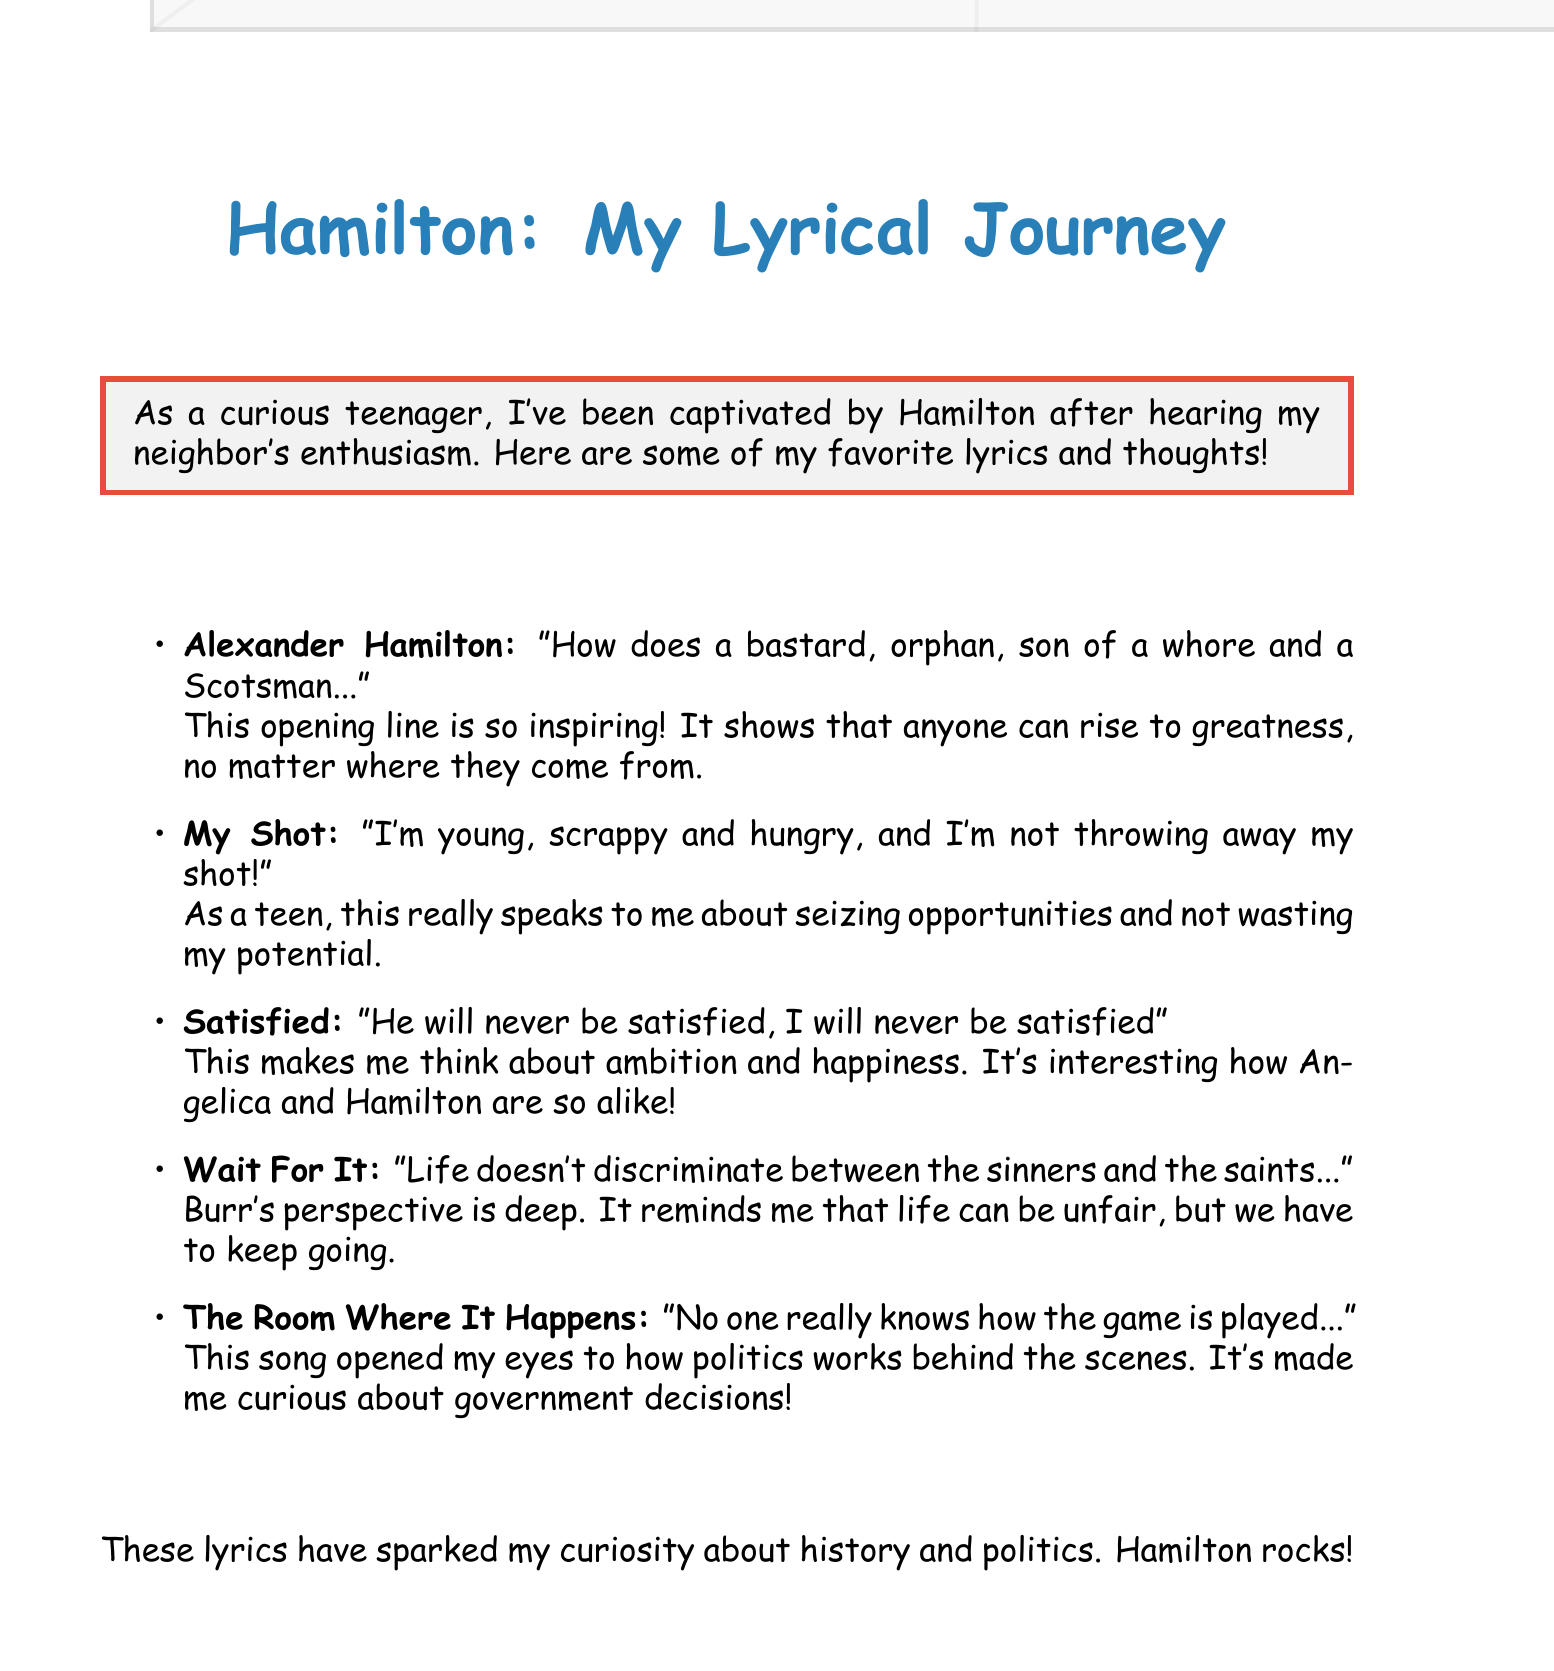What is the title of the first song? The title of the first song mentioned in the document is "Alexander Hamilton."
Answer: Alexander Hamilton What line is quoted from "My Shot"? The document quotes, "I'm just like my country, I'm young, scrappy and hungry, and I'm not throwing away my shot!"
Answer: I'm just like my country, I'm young, scrappy and hungry, and I'm not throwing away my shot! Who expresses that they will never be satisfied? The line "He will never be satisfied, I will never be satisfied" is associated with Angelica and Hamilton.
Answer: Angelica and Hamilton What theme is associated with the song "Wait For It"? The theme revolves around the unfairness of life as expressed in the line about life taking from everyone.
Answer: Unfairness of life Which song highlights the hidden nature of political dealings? The song highlighting this theme is "The Room Where It Happens."
Answer: The Room Where It Happens How does the document describe the author's feelings towards Hamilton? The document expresses that Hamilton has sparked curiosity about history and politics for the author.
Answer: Curiosity about history and politics 